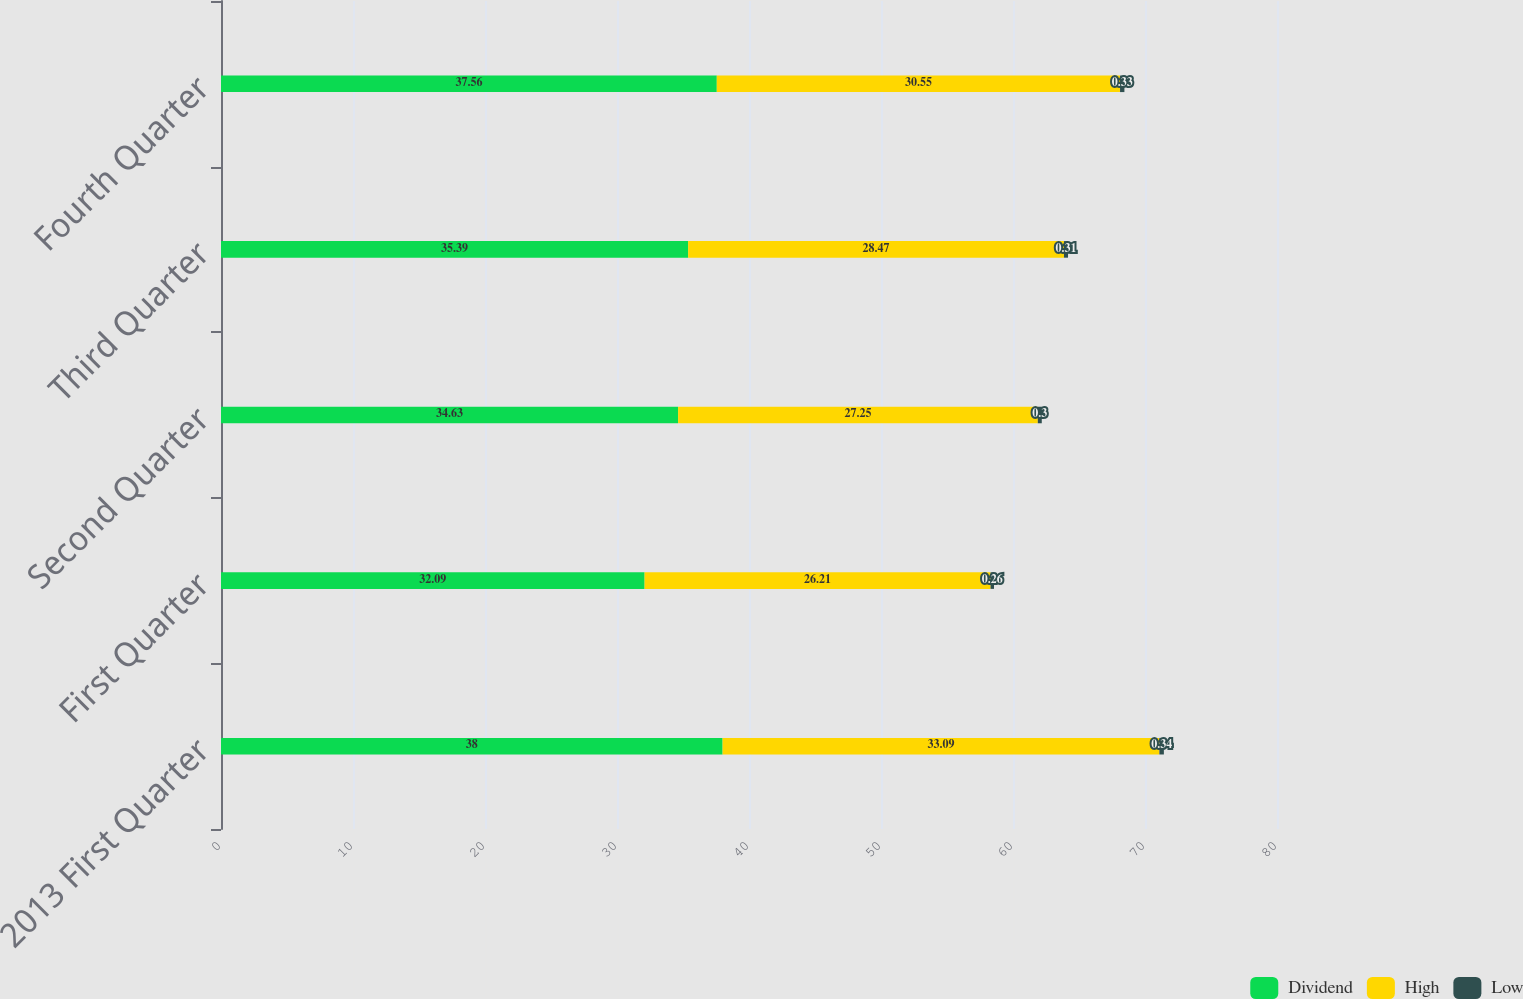Convert chart to OTSL. <chart><loc_0><loc_0><loc_500><loc_500><stacked_bar_chart><ecel><fcel>2013 First Quarter<fcel>First Quarter<fcel>Second Quarter<fcel>Third Quarter<fcel>Fourth Quarter<nl><fcel>Dividend<fcel>38<fcel>32.09<fcel>34.63<fcel>35.39<fcel>37.56<nl><fcel>High<fcel>33.09<fcel>26.21<fcel>27.25<fcel>28.47<fcel>30.55<nl><fcel>Low<fcel>0.34<fcel>0.26<fcel>0.3<fcel>0.31<fcel>0.33<nl></chart> 